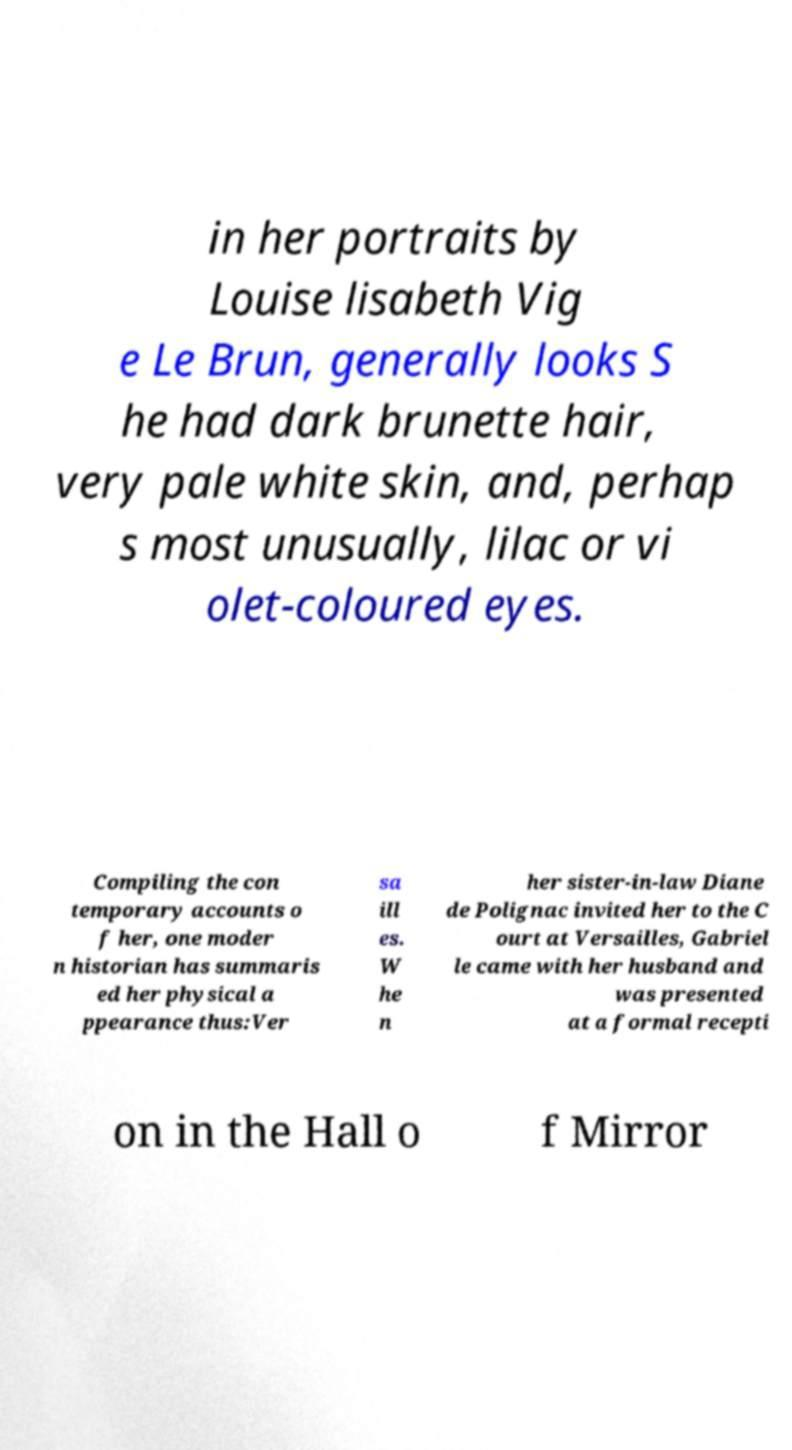Could you extract and type out the text from this image? in her portraits by Louise lisabeth Vig e Le Brun, generally looks S he had dark brunette hair, very pale white skin, and, perhap s most unusually, lilac or vi olet-coloured eyes. Compiling the con temporary accounts o f her, one moder n historian has summaris ed her physical a ppearance thus:Ver sa ill es. W he n her sister-in-law Diane de Polignac invited her to the C ourt at Versailles, Gabriel le came with her husband and was presented at a formal recepti on in the Hall o f Mirror 